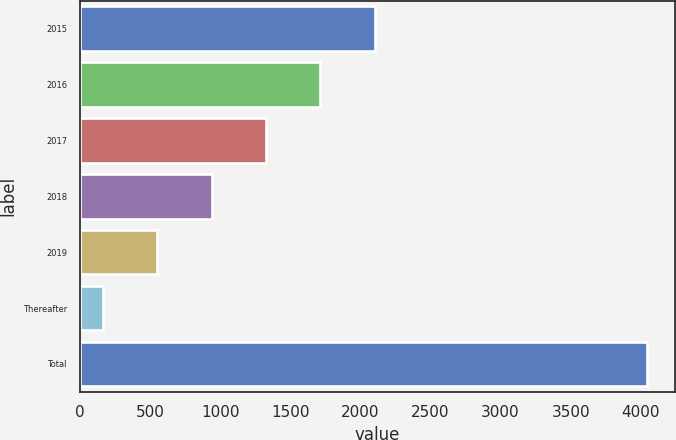<chart> <loc_0><loc_0><loc_500><loc_500><bar_chart><fcel>2015<fcel>2016<fcel>2017<fcel>2018<fcel>2019<fcel>Thereafter<fcel>Total<nl><fcel>2102.5<fcel>1714.6<fcel>1326.7<fcel>938.8<fcel>550.9<fcel>163<fcel>4042<nl></chart> 